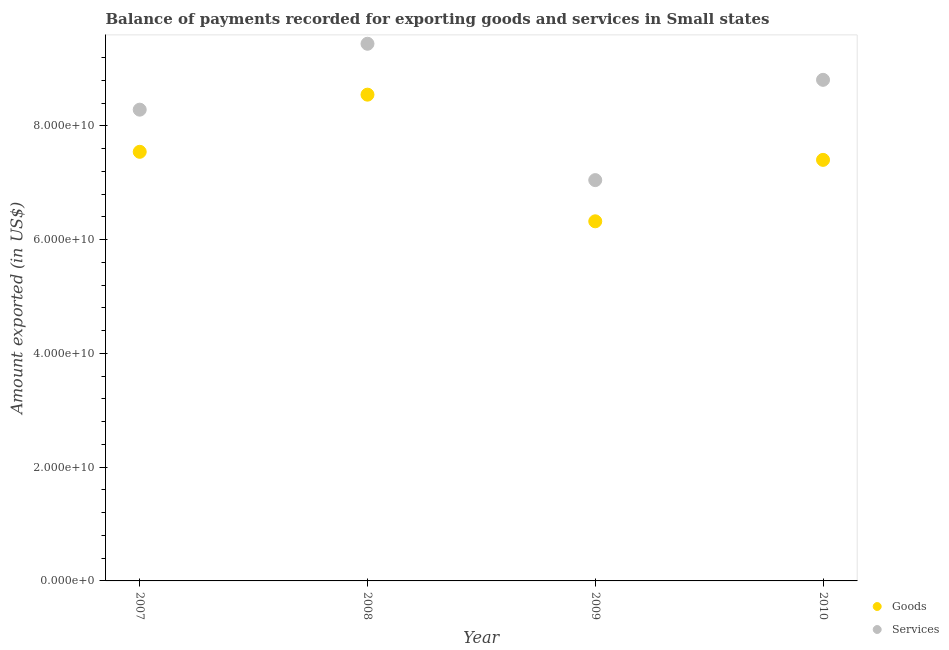How many different coloured dotlines are there?
Your answer should be compact. 2. What is the amount of goods exported in 2007?
Give a very brief answer. 7.54e+1. Across all years, what is the maximum amount of goods exported?
Give a very brief answer. 8.55e+1. Across all years, what is the minimum amount of goods exported?
Your answer should be compact. 6.32e+1. In which year was the amount of services exported minimum?
Your response must be concise. 2009. What is the total amount of goods exported in the graph?
Your answer should be very brief. 2.98e+11. What is the difference between the amount of goods exported in 2008 and that in 2010?
Offer a terse response. 1.15e+1. What is the difference between the amount of services exported in 2007 and the amount of goods exported in 2009?
Ensure brevity in your answer.  1.96e+1. What is the average amount of goods exported per year?
Your answer should be very brief. 7.45e+1. In the year 2010, what is the difference between the amount of services exported and amount of goods exported?
Make the answer very short. 1.41e+1. What is the ratio of the amount of goods exported in 2008 to that in 2009?
Provide a short and direct response. 1.35. Is the difference between the amount of goods exported in 2007 and 2008 greater than the difference between the amount of services exported in 2007 and 2008?
Offer a terse response. Yes. What is the difference between the highest and the second highest amount of goods exported?
Keep it short and to the point. 1.00e+1. What is the difference between the highest and the lowest amount of services exported?
Provide a succinct answer. 2.40e+1. In how many years, is the amount of goods exported greater than the average amount of goods exported taken over all years?
Provide a succinct answer. 2. Is the sum of the amount of services exported in 2007 and 2010 greater than the maximum amount of goods exported across all years?
Make the answer very short. Yes. Is the amount of services exported strictly less than the amount of goods exported over the years?
Give a very brief answer. No. How many dotlines are there?
Your answer should be compact. 2. Are the values on the major ticks of Y-axis written in scientific E-notation?
Offer a very short reply. Yes. Does the graph contain grids?
Your answer should be very brief. No. How many legend labels are there?
Your response must be concise. 2. What is the title of the graph?
Give a very brief answer. Balance of payments recorded for exporting goods and services in Small states. Does "Malaria" appear as one of the legend labels in the graph?
Ensure brevity in your answer.  No. What is the label or title of the Y-axis?
Your answer should be very brief. Amount exported (in US$). What is the Amount exported (in US$) in Goods in 2007?
Keep it short and to the point. 7.54e+1. What is the Amount exported (in US$) of Services in 2007?
Give a very brief answer. 8.28e+1. What is the Amount exported (in US$) in Goods in 2008?
Offer a very short reply. 8.55e+1. What is the Amount exported (in US$) of Services in 2008?
Offer a terse response. 9.44e+1. What is the Amount exported (in US$) in Goods in 2009?
Offer a terse response. 6.32e+1. What is the Amount exported (in US$) in Services in 2009?
Keep it short and to the point. 7.05e+1. What is the Amount exported (in US$) of Goods in 2010?
Provide a short and direct response. 7.40e+1. What is the Amount exported (in US$) in Services in 2010?
Give a very brief answer. 8.81e+1. Across all years, what is the maximum Amount exported (in US$) in Goods?
Offer a terse response. 8.55e+1. Across all years, what is the maximum Amount exported (in US$) of Services?
Offer a terse response. 9.44e+1. Across all years, what is the minimum Amount exported (in US$) of Goods?
Provide a succinct answer. 6.32e+1. Across all years, what is the minimum Amount exported (in US$) in Services?
Your answer should be very brief. 7.05e+1. What is the total Amount exported (in US$) of Goods in the graph?
Provide a short and direct response. 2.98e+11. What is the total Amount exported (in US$) of Services in the graph?
Provide a short and direct response. 3.36e+11. What is the difference between the Amount exported (in US$) in Goods in 2007 and that in 2008?
Offer a very short reply. -1.00e+1. What is the difference between the Amount exported (in US$) of Services in 2007 and that in 2008?
Provide a succinct answer. -1.16e+1. What is the difference between the Amount exported (in US$) of Goods in 2007 and that in 2009?
Your answer should be compact. 1.22e+1. What is the difference between the Amount exported (in US$) of Services in 2007 and that in 2009?
Provide a succinct answer. 1.24e+1. What is the difference between the Amount exported (in US$) of Goods in 2007 and that in 2010?
Your response must be concise. 1.42e+09. What is the difference between the Amount exported (in US$) in Services in 2007 and that in 2010?
Provide a succinct answer. -5.24e+09. What is the difference between the Amount exported (in US$) of Goods in 2008 and that in 2009?
Keep it short and to the point. 2.23e+1. What is the difference between the Amount exported (in US$) of Services in 2008 and that in 2009?
Offer a terse response. 2.40e+1. What is the difference between the Amount exported (in US$) of Goods in 2008 and that in 2010?
Make the answer very short. 1.15e+1. What is the difference between the Amount exported (in US$) in Services in 2008 and that in 2010?
Provide a succinct answer. 6.34e+09. What is the difference between the Amount exported (in US$) in Goods in 2009 and that in 2010?
Offer a terse response. -1.08e+1. What is the difference between the Amount exported (in US$) of Services in 2009 and that in 2010?
Provide a short and direct response. -1.76e+1. What is the difference between the Amount exported (in US$) of Goods in 2007 and the Amount exported (in US$) of Services in 2008?
Provide a short and direct response. -1.90e+1. What is the difference between the Amount exported (in US$) of Goods in 2007 and the Amount exported (in US$) of Services in 2009?
Give a very brief answer. 4.97e+09. What is the difference between the Amount exported (in US$) of Goods in 2007 and the Amount exported (in US$) of Services in 2010?
Provide a succinct answer. -1.27e+1. What is the difference between the Amount exported (in US$) of Goods in 2008 and the Amount exported (in US$) of Services in 2009?
Provide a short and direct response. 1.50e+1. What is the difference between the Amount exported (in US$) of Goods in 2008 and the Amount exported (in US$) of Services in 2010?
Your answer should be compact. -2.61e+09. What is the difference between the Amount exported (in US$) of Goods in 2009 and the Amount exported (in US$) of Services in 2010?
Give a very brief answer. -2.49e+1. What is the average Amount exported (in US$) of Goods per year?
Your answer should be compact. 7.45e+1. What is the average Amount exported (in US$) of Services per year?
Provide a short and direct response. 8.39e+1. In the year 2007, what is the difference between the Amount exported (in US$) of Goods and Amount exported (in US$) of Services?
Give a very brief answer. -7.41e+09. In the year 2008, what is the difference between the Amount exported (in US$) of Goods and Amount exported (in US$) of Services?
Make the answer very short. -8.95e+09. In the year 2009, what is the difference between the Amount exported (in US$) of Goods and Amount exported (in US$) of Services?
Ensure brevity in your answer.  -7.24e+09. In the year 2010, what is the difference between the Amount exported (in US$) in Goods and Amount exported (in US$) in Services?
Your answer should be compact. -1.41e+1. What is the ratio of the Amount exported (in US$) in Goods in 2007 to that in 2008?
Provide a short and direct response. 0.88. What is the ratio of the Amount exported (in US$) of Services in 2007 to that in 2008?
Keep it short and to the point. 0.88. What is the ratio of the Amount exported (in US$) of Goods in 2007 to that in 2009?
Your response must be concise. 1.19. What is the ratio of the Amount exported (in US$) of Services in 2007 to that in 2009?
Provide a short and direct response. 1.18. What is the ratio of the Amount exported (in US$) in Goods in 2007 to that in 2010?
Offer a terse response. 1.02. What is the ratio of the Amount exported (in US$) in Services in 2007 to that in 2010?
Your response must be concise. 0.94. What is the ratio of the Amount exported (in US$) of Goods in 2008 to that in 2009?
Provide a succinct answer. 1.35. What is the ratio of the Amount exported (in US$) in Services in 2008 to that in 2009?
Make the answer very short. 1.34. What is the ratio of the Amount exported (in US$) of Goods in 2008 to that in 2010?
Your response must be concise. 1.15. What is the ratio of the Amount exported (in US$) of Services in 2008 to that in 2010?
Offer a very short reply. 1.07. What is the ratio of the Amount exported (in US$) of Goods in 2009 to that in 2010?
Your response must be concise. 0.85. What is the ratio of the Amount exported (in US$) in Services in 2009 to that in 2010?
Offer a terse response. 0.8. What is the difference between the highest and the second highest Amount exported (in US$) in Goods?
Keep it short and to the point. 1.00e+1. What is the difference between the highest and the second highest Amount exported (in US$) in Services?
Ensure brevity in your answer.  6.34e+09. What is the difference between the highest and the lowest Amount exported (in US$) in Goods?
Offer a terse response. 2.23e+1. What is the difference between the highest and the lowest Amount exported (in US$) in Services?
Your answer should be compact. 2.40e+1. 